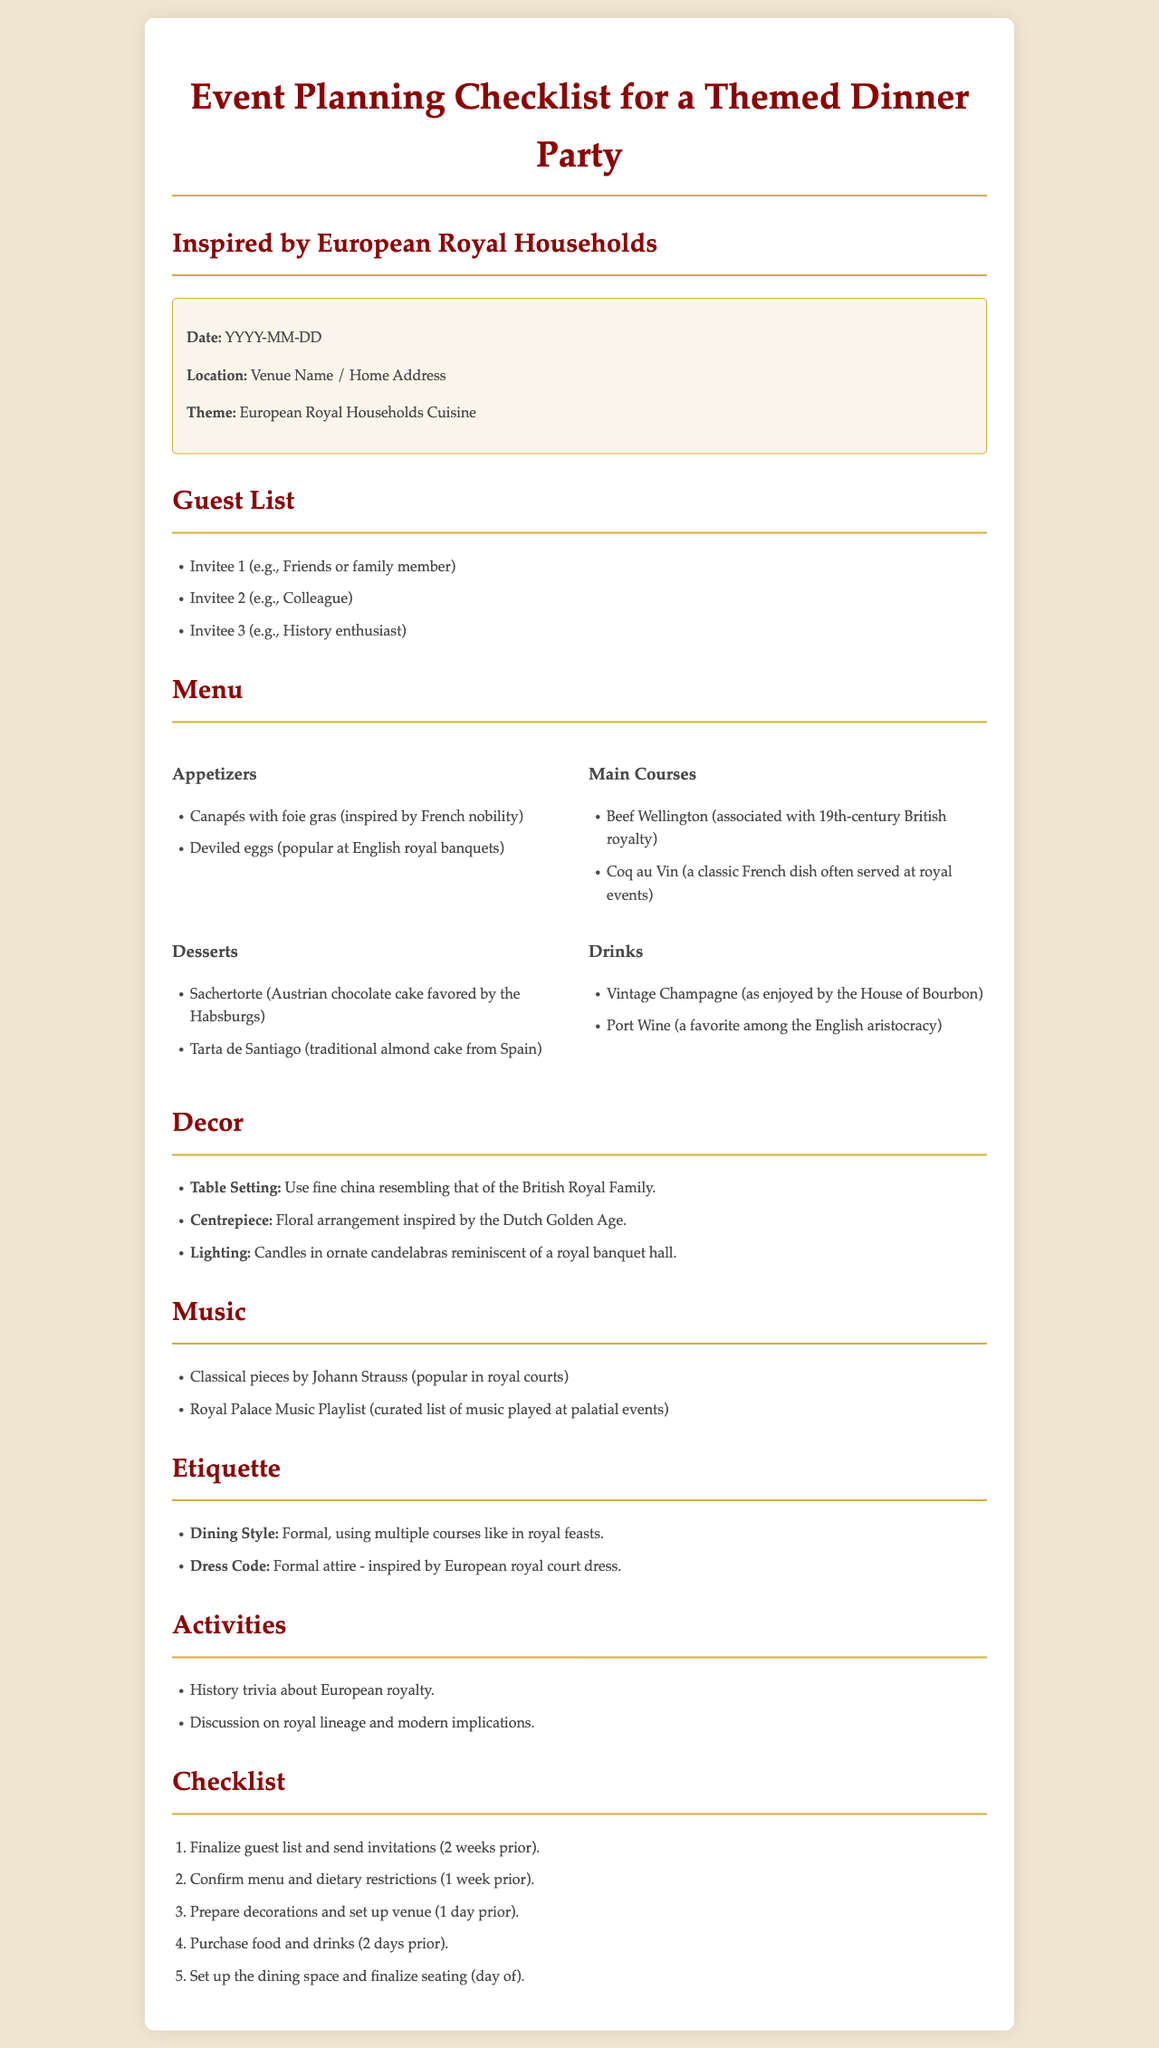What is the date for the dinner party? The document lists the date as a placeholder labeled "YYYY-MM-DD."
Answer: YYYY-MM-DD What type of cuisine is the theme inspired by? The theme is stated as "European Royal Households Cuisine."
Answer: European Royal Households Cuisine Name an appetizer from the menu. The appetizers listed include "Canapés with foie gras" and "Deviled eggs."
Answer: Canapés with foie gras What is the dress code for the dinner party? The dress code is specified as "Formal attire - inspired by European royal court dress."
Answer: Formal attire - inspired by European royal court dress What type of music is suggested for the party? The document mentions "Classical pieces by Johann Strauss" and "Royal Palace Music Playlist."
Answer: Classical pieces by Johann Strauss How many days prior to the event should food and drinks be purchased? The checklist indicates purchasing food and drinks should occur "2 days prior."
Answer: 2 days prior Who is one potential invitee from the guest list? The guest list includes "Friends or family member," "Colleague," or "History enthusiast."
Answer: Friends or family member What is one activity planned for the dinner party? The activities include "History trivia about European royalty" and "Discussion on royal lineage and modern implications."
Answer: History trivia about European royalty What is a recommended drink for the dinner party? The drinks mentioned are "Vintage Champagne" and "Port Wine."
Answer: Vintage Champagne 